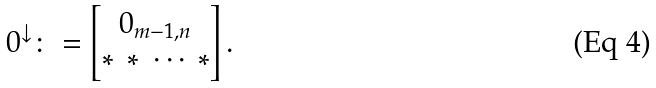Convert formula to latex. <formula><loc_0><loc_0><loc_500><loc_500>0 ^ { \downarrow } \colon = \begin{bmatrix} 0 _ { m - 1 , n } \\ * \ * \ \cdots \ * \end{bmatrix} .</formula> 